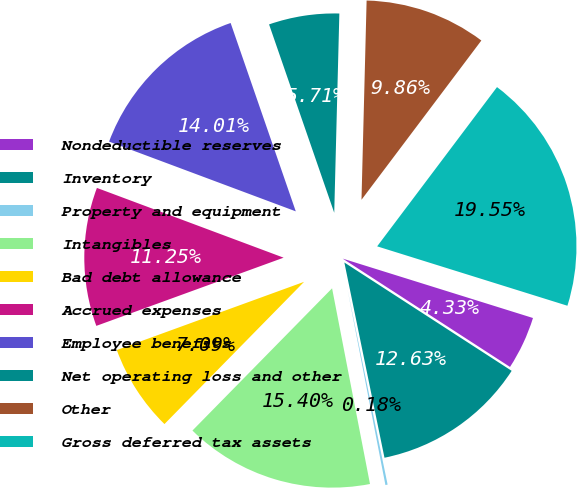Convert chart. <chart><loc_0><loc_0><loc_500><loc_500><pie_chart><fcel>Nondeductible reserves<fcel>Inventory<fcel>Property and equipment<fcel>Intangibles<fcel>Bad debt allowance<fcel>Accrued expenses<fcel>Employee benefits<fcel>Net operating loss and other<fcel>Other<fcel>Gross deferred tax assets<nl><fcel>4.33%<fcel>12.63%<fcel>0.18%<fcel>15.4%<fcel>7.09%<fcel>11.25%<fcel>14.01%<fcel>5.71%<fcel>9.86%<fcel>19.55%<nl></chart> 